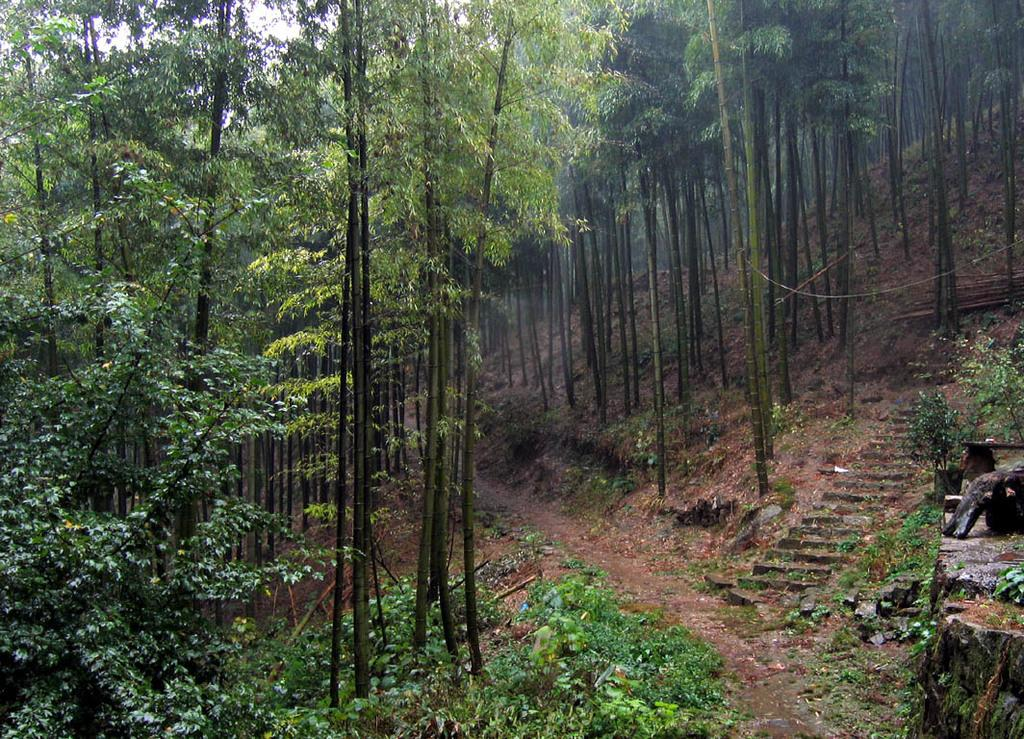What type of vegetation can be seen in the image? There are trees and plants in the image. What architectural feature is present in the image? There are steps in the image. What type of surface is visible on the ground in the image? There is grass on the ground in the image. What can be seen in the background of the image? The sky is visible in the background of the image. Is there a designated route or path in the image? Yes, there is a path in the image. What type of silk fabric is draped over the trees in the image? There is no silk fabric present in the image; it features trees, plants, steps, a path, grass, and the sky. How many accounts are visible in the image? There are no accounts present in the image; it is a natural scene with trees, plants, steps, a path, grass, and the sky. 